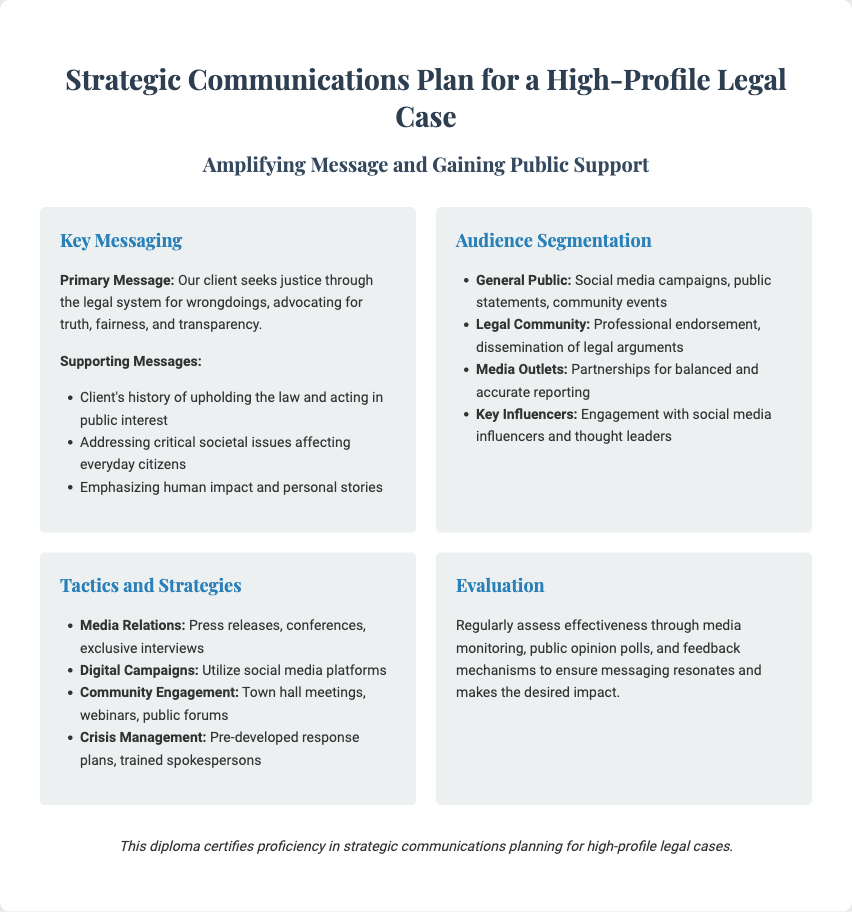What is the primary message? The primary message is stated in the Key Messaging section, advocating for justice through the legal system for wrongdoings.
Answer: Our client seeks justice through the legal system for wrongdoings, advocating for truth, fairness, and transparency What type of audience is targeted for social media campaigns? Social media campaigns are aimed at the General Public according to the Audience Segmentation section.
Answer: General Public What is one tactic used in media relations? A specific tactic under Media Relations is detailed in the Tactics and Strategies section which discusses different media outreach methods.
Answer: Press releases What should be regularly assessed for effectiveness? The Evaluation section recommends specific methods for assessing the effectiveness of the communications plan.
Answer: Effectiveness How many supporting messages are listed? In the Key Messaging section, there are several supporting messages mentioned that provide additional context to the primary message.
Answer: Three 